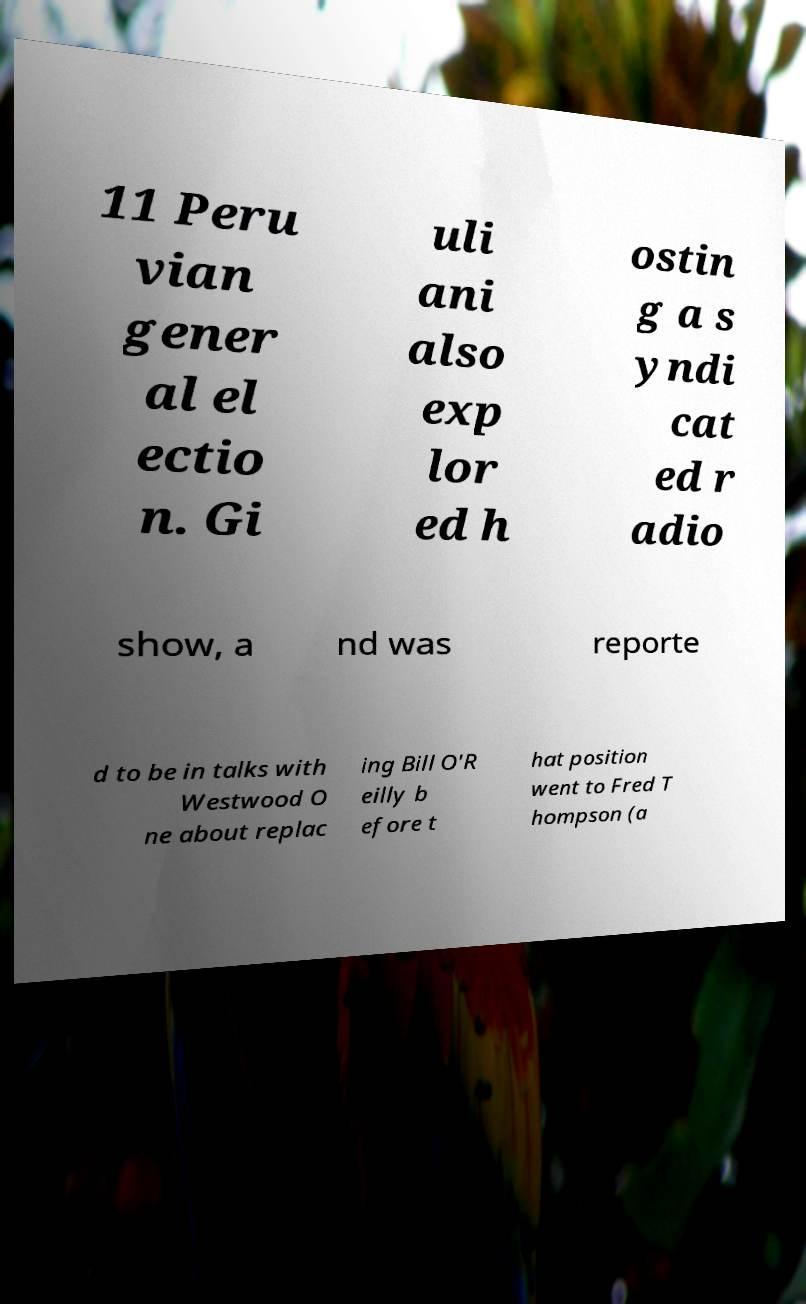Can you read and provide the text displayed in the image?This photo seems to have some interesting text. Can you extract and type it out for me? 11 Peru vian gener al el ectio n. Gi uli ani also exp lor ed h ostin g a s yndi cat ed r adio show, a nd was reporte d to be in talks with Westwood O ne about replac ing Bill O'R eilly b efore t hat position went to Fred T hompson (a 